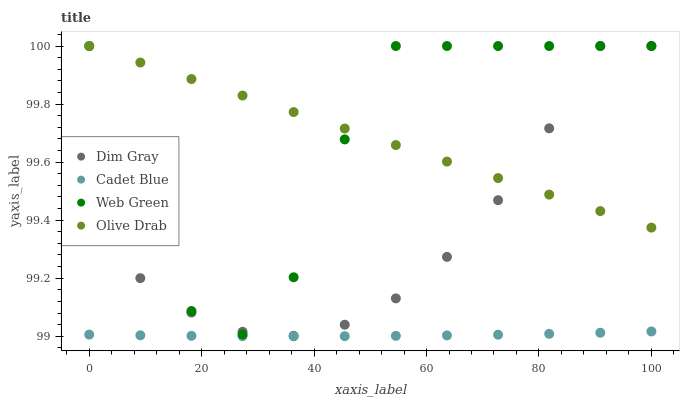Does Cadet Blue have the minimum area under the curve?
Answer yes or no. Yes. Does Olive Drab have the maximum area under the curve?
Answer yes or no. Yes. Does Dim Gray have the minimum area under the curve?
Answer yes or no. No. Does Dim Gray have the maximum area under the curve?
Answer yes or no. No. Is Olive Drab the smoothest?
Answer yes or no. Yes. Is Web Green the roughest?
Answer yes or no. Yes. Is Dim Gray the smoothest?
Answer yes or no. No. Is Dim Gray the roughest?
Answer yes or no. No. Does Cadet Blue have the lowest value?
Answer yes or no. Yes. Does Dim Gray have the lowest value?
Answer yes or no. No. Does Web Green have the highest value?
Answer yes or no. Yes. Is Cadet Blue less than Web Green?
Answer yes or no. Yes. Is Olive Drab greater than Cadet Blue?
Answer yes or no. Yes. Does Web Green intersect Dim Gray?
Answer yes or no. Yes. Is Web Green less than Dim Gray?
Answer yes or no. No. Is Web Green greater than Dim Gray?
Answer yes or no. No. Does Cadet Blue intersect Web Green?
Answer yes or no. No. 